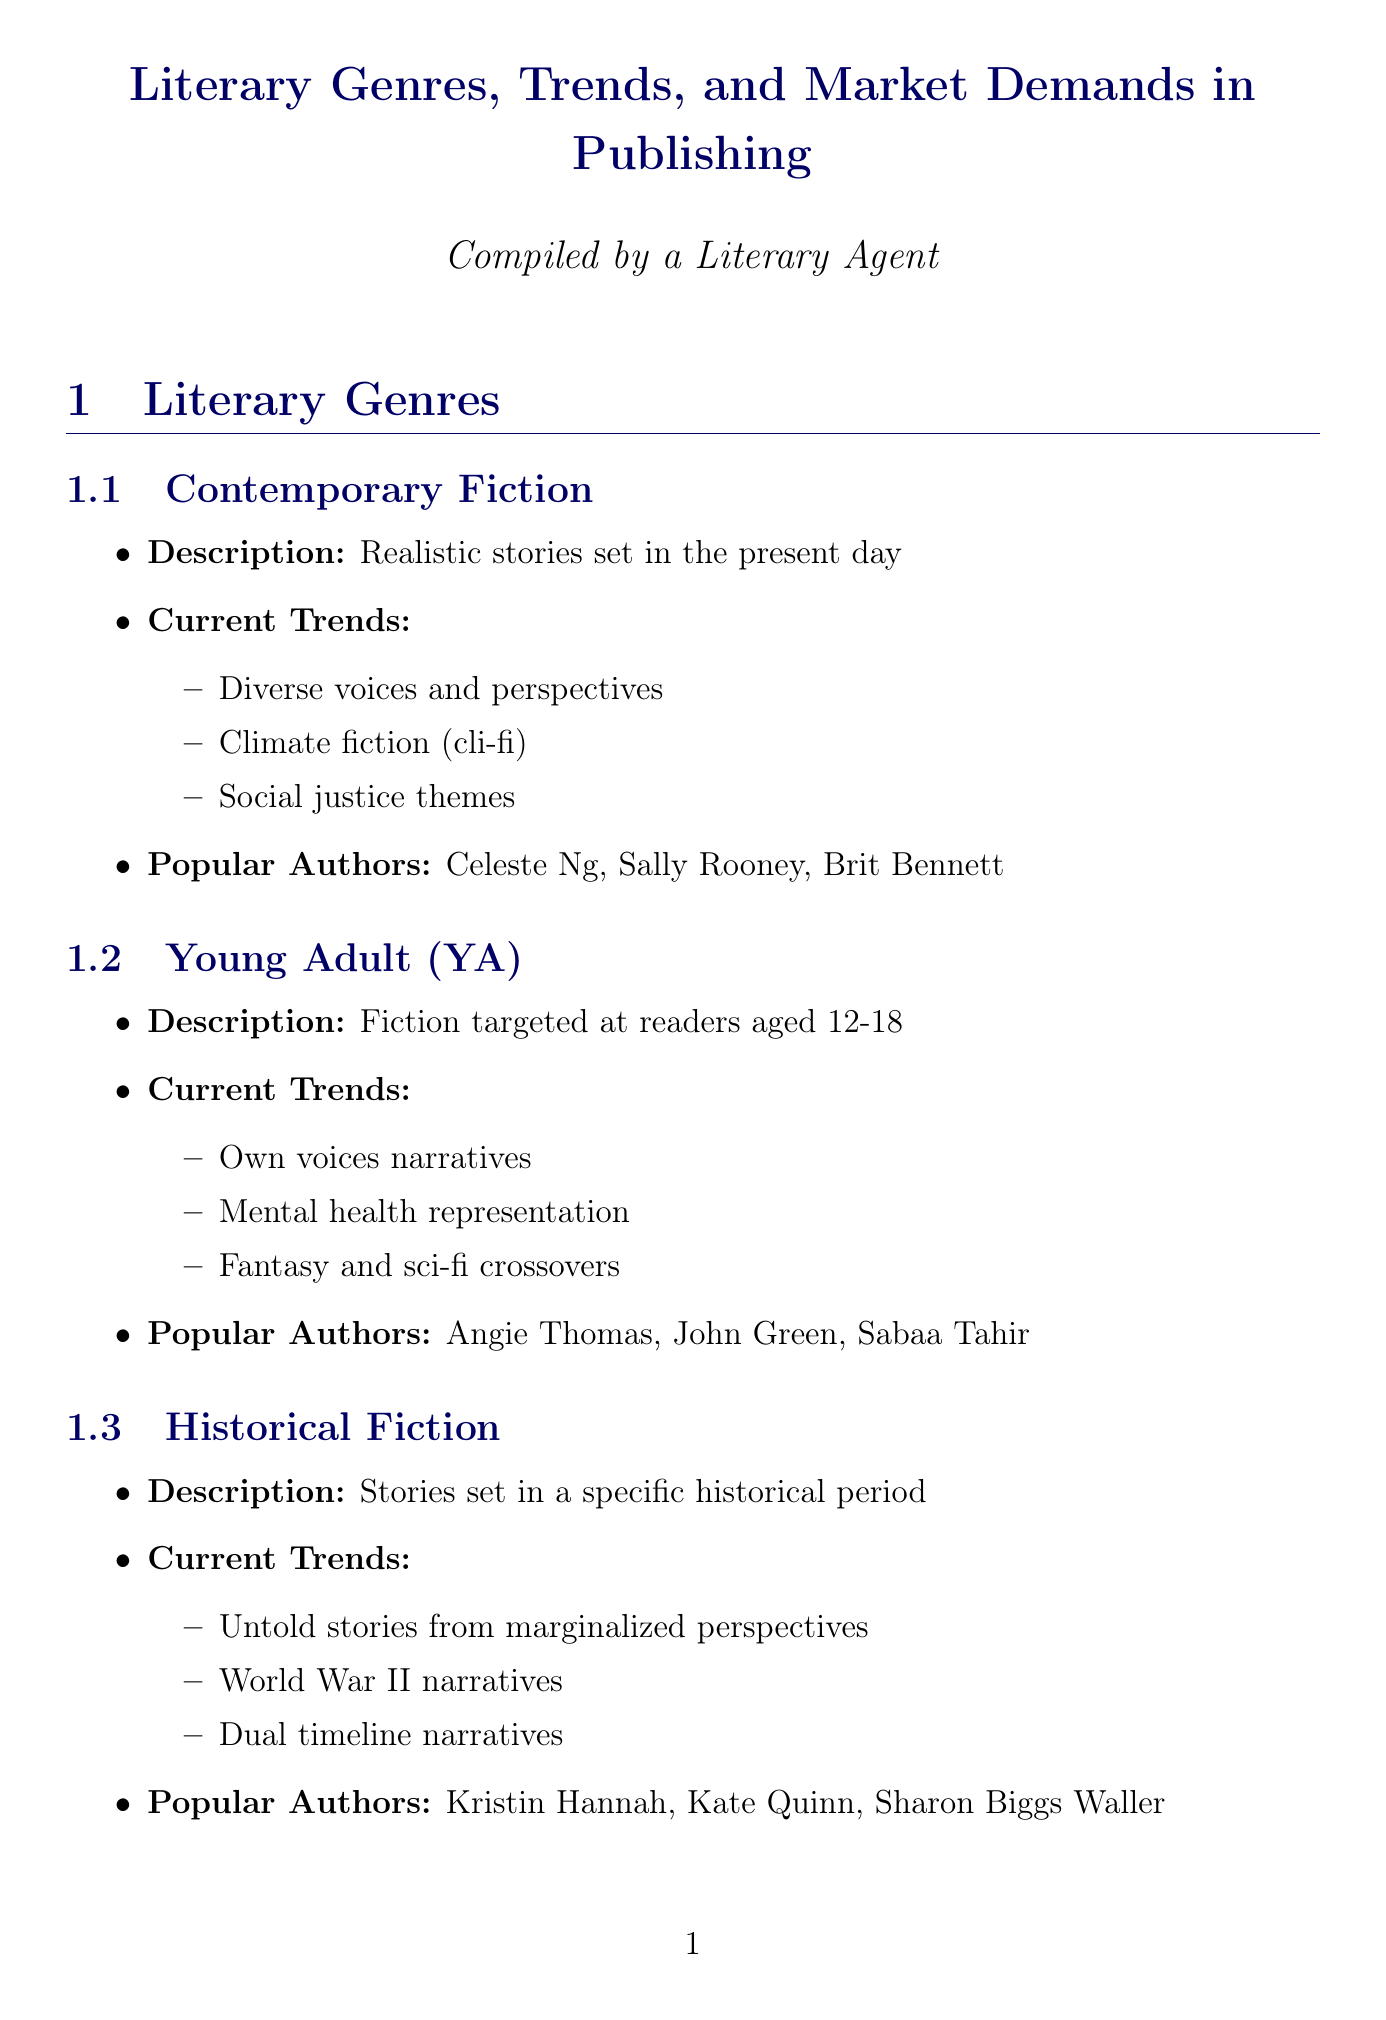What is the description of Contemporary Fiction? The document states that Contemporary Fiction consists of realistic stories set in the present day.
Answer: Realistic stories set in the present day Who are the popular authors in Historical Fiction? The document lists the popular authors in Historical Fiction, which includes Kristin Hannah, Kate Quinn, and Sharon Biggs Waller.
Answer: Kristin Hannah, Kate Quinn, Sharon Biggs Waller What is a current trend in Young Adult (YA) literature? The document mentions current trends in YA, specifically highlighting own voices narratives.
Answer: Own voices narratives What is the impact of the Audiobook Market trend? The document describes the impact as agents negotiating separate audio rights and increased production value.
Answer: Agents negotiating separate audio rights, increased production value What advice is given about Query Letters? The document states the advice for Query Letters is to personalize your query and show knowledge of the agent's list.
Answer: Personalize your query, show knowledge of the agent's list What is the main topic of the section titled "Agent Insights"? The section outlines various aspects of the author-agent relationship and includes tips on query letters and contract negotiation.
Answer: Author-Agent Relationship Which book is an example of the Diversity and Inclusion market demand? The document provides examples such as The Vanishing Half by Brit Bennett.
Answer: The Vanishing Half What trend describes self-published authors achieving mainstream success? The document refers to this trend as Indie Author Success.
Answer: Indie Author Success Which resource provides industry news and deal reporting? The document lists Publishers Marketplace as a resource that provides industry news and deal reporting.
Answer: Publishers Marketplace 